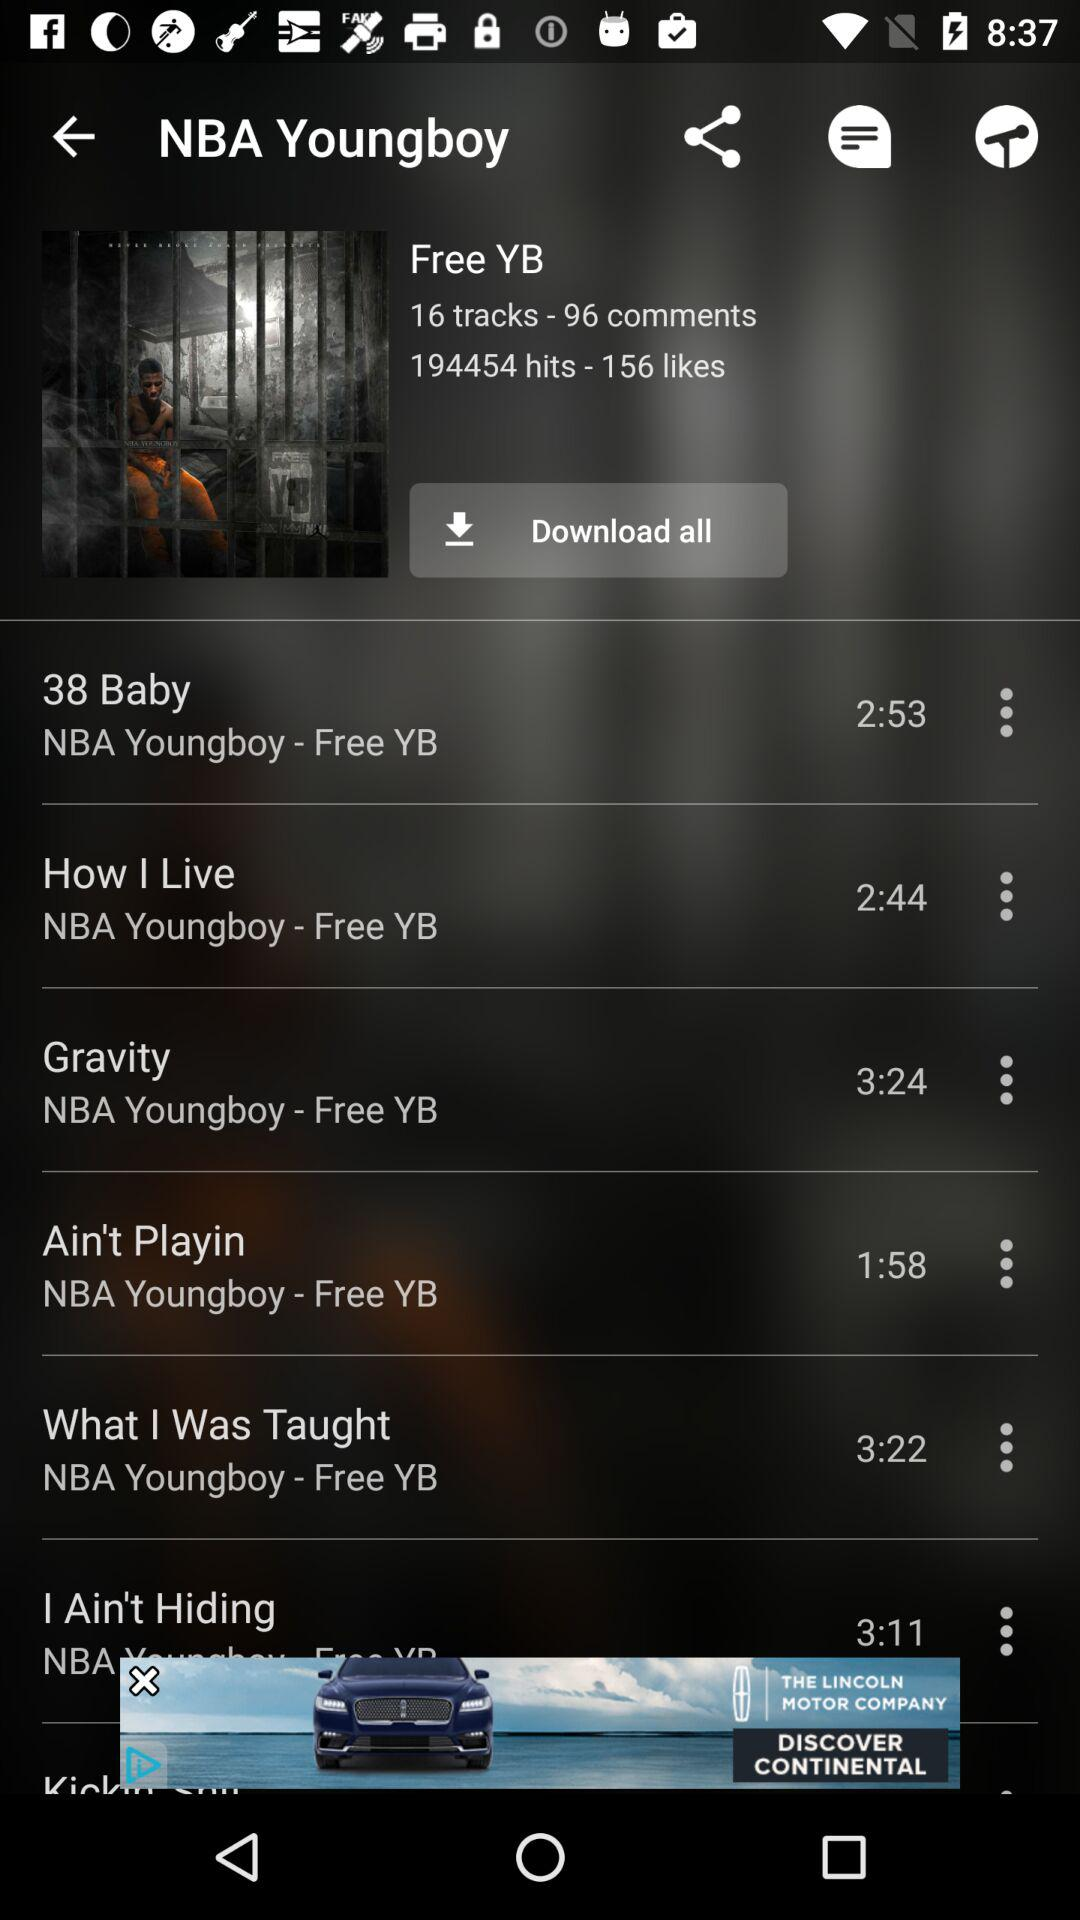How many tracks are in the album?
Answer the question using a single word or phrase. 16 